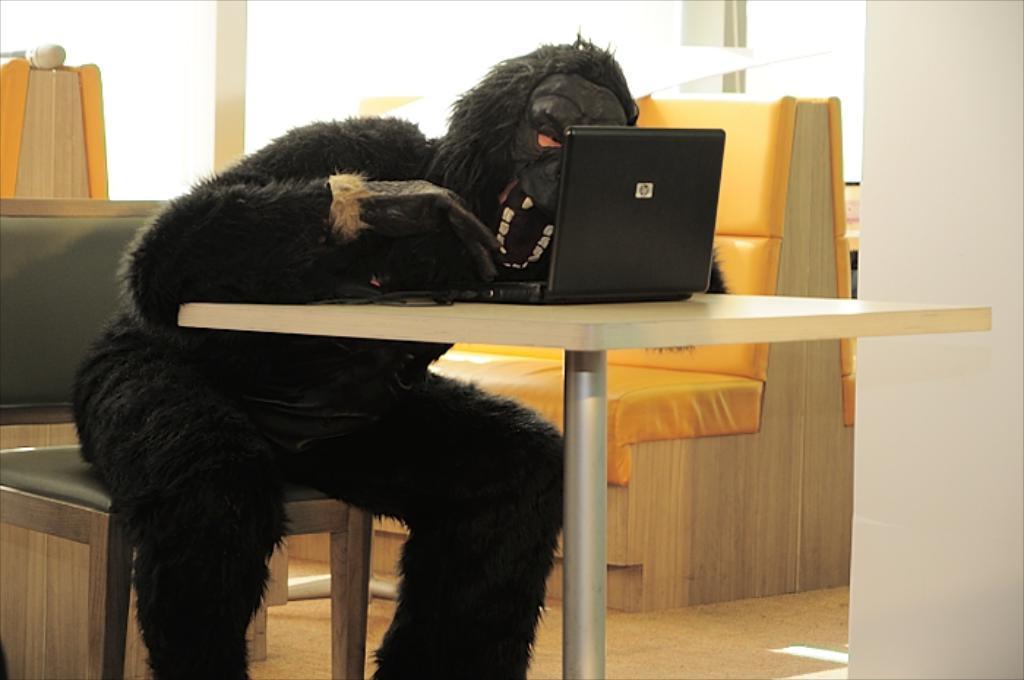How would you summarize this image in a sentence or two? In this picture there is a man sitting on the chair beside the table. He is wearing an animal costume. On the table, there is a laptop. In the background, there are sofas. 